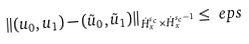<formula> <loc_0><loc_0><loc_500><loc_500>\left \| ( u _ { 0 } , u _ { 1 } ) - ( \tilde { u } _ { 0 } , \tilde { u } _ { 1 } ) \right \| _ { \dot { H } _ { x } ^ { s _ { c } } \times \dot { H } _ { x } ^ { s _ { c } - 1 } } & \leq \ e p s</formula> 